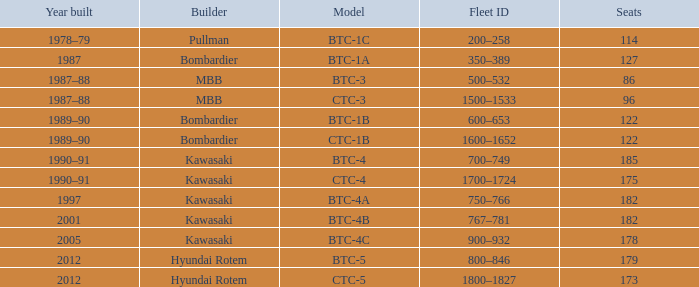In what year was the ctc-3 model built? 1987–88. 